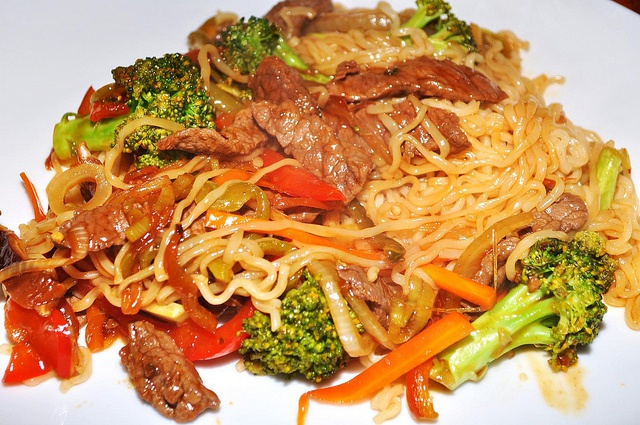Describe the objects in this image and their specific colors. I can see broccoli in lightgray, olive, khaki, and gold tones, broccoli in lightgray, olive, and black tones, carrot in lightgray, red, brown, and tan tones, broccoli in lightgray, olive, and black tones, and carrot in lightgray, red, and orange tones in this image. 